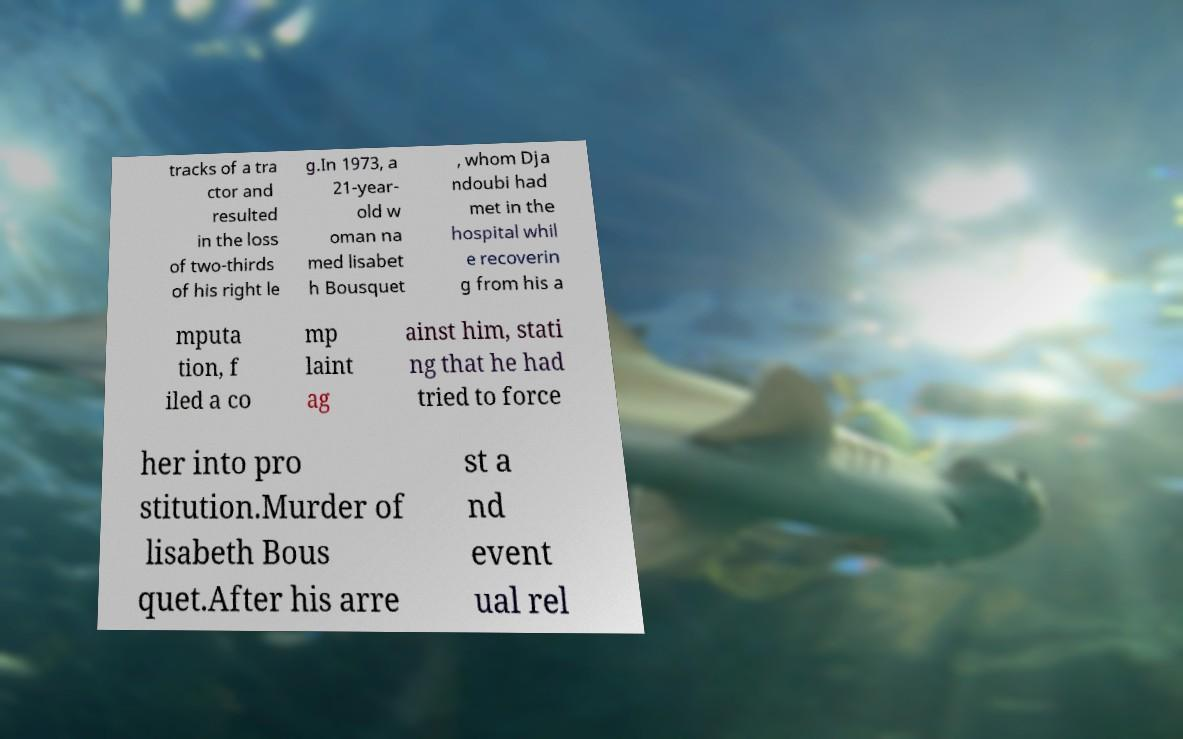Could you extract and type out the text from this image? tracks of a tra ctor and resulted in the loss of two-thirds of his right le g.In 1973, a 21-year- old w oman na med lisabet h Bousquet , whom Dja ndoubi had met in the hospital whil e recoverin g from his a mputa tion, f iled a co mp laint ag ainst him, stati ng that he had tried to force her into pro stitution.Murder of lisabeth Bous quet.After his arre st a nd event ual rel 